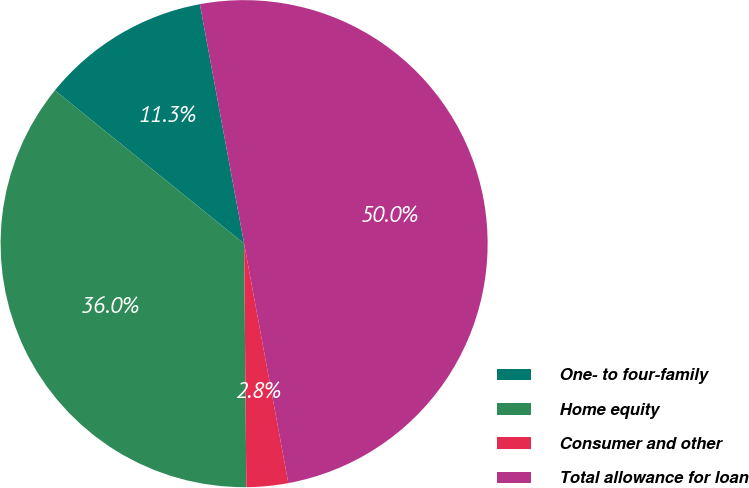<chart> <loc_0><loc_0><loc_500><loc_500><pie_chart><fcel>One- to four-family<fcel>Home equity<fcel>Consumer and other<fcel>Total allowance for loan<nl><fcel>11.26%<fcel>35.98%<fcel>2.76%<fcel>50.0%<nl></chart> 